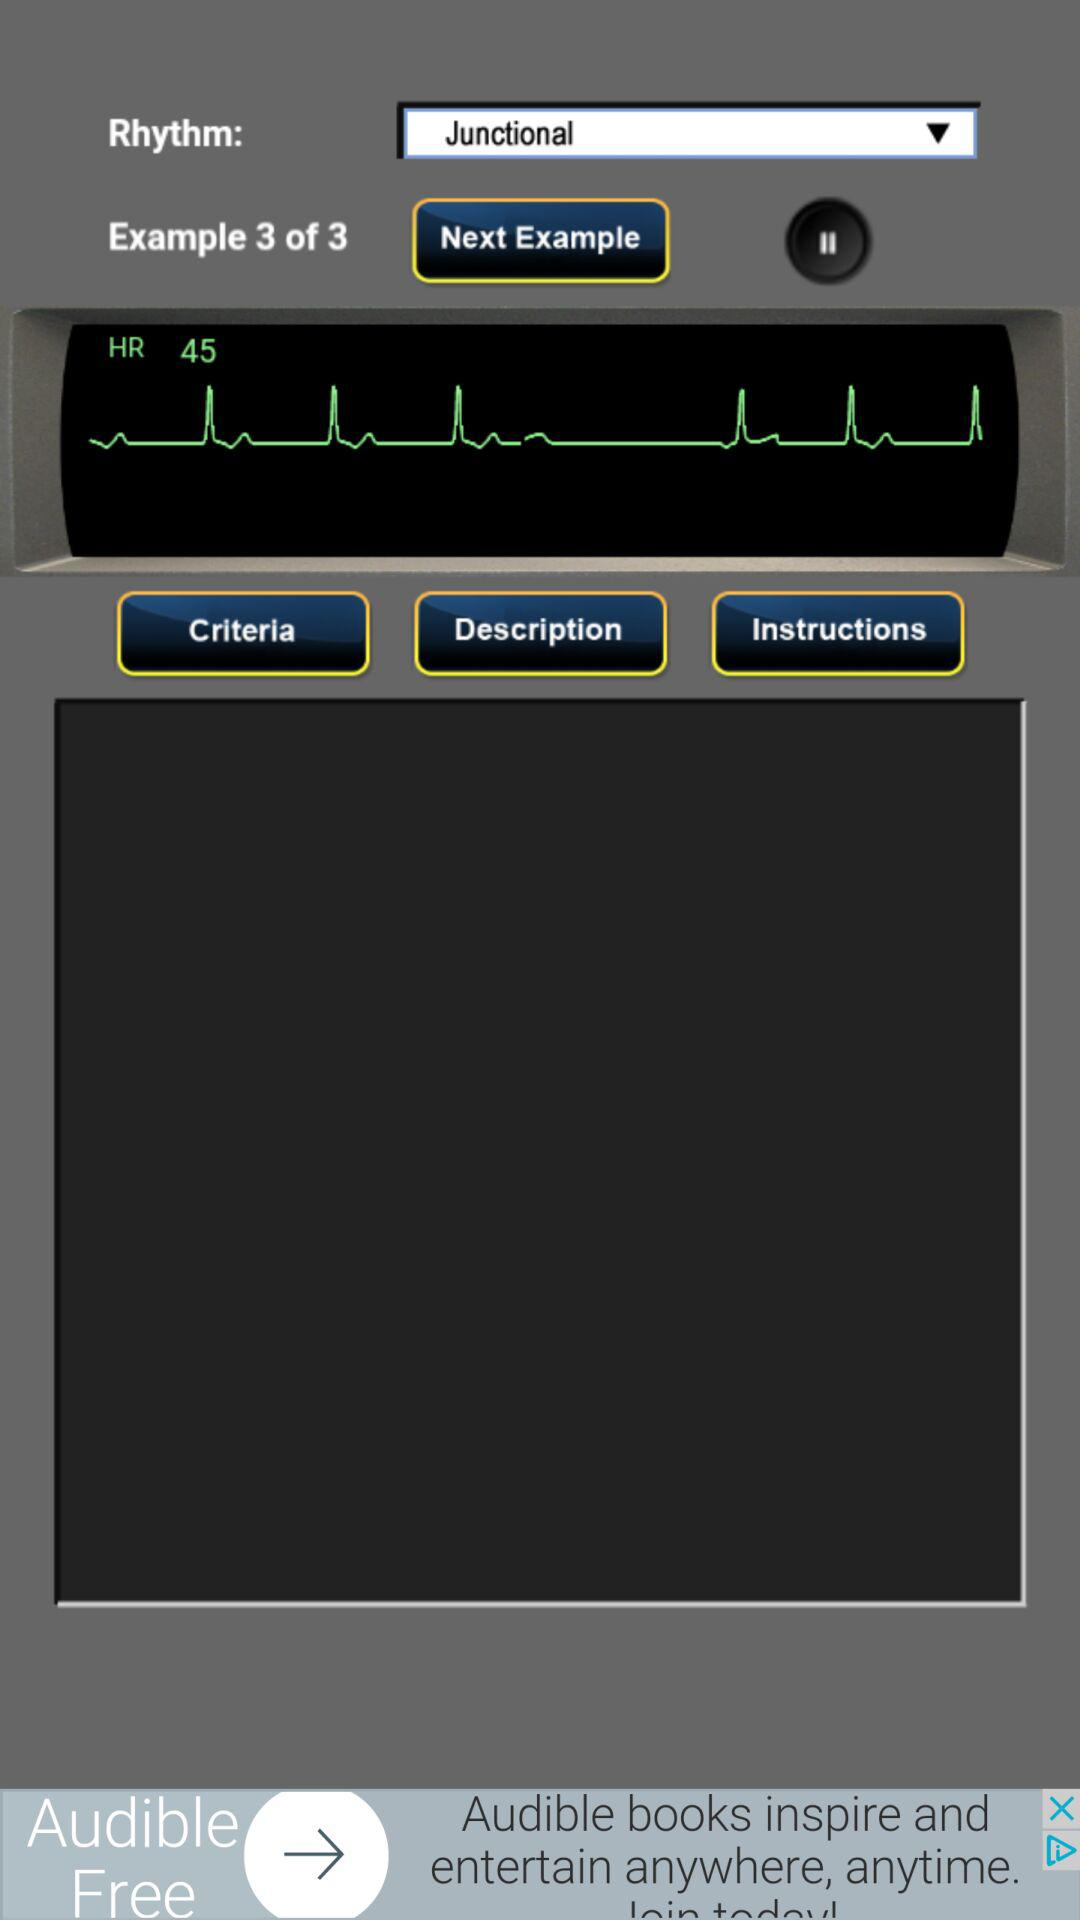How many examples in total are there? There are 3 examples. 